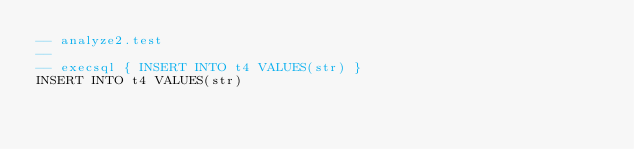Convert code to text. <code><loc_0><loc_0><loc_500><loc_500><_SQL_>-- analyze2.test
-- 
-- execsql { INSERT INTO t4 VALUES(str) }
INSERT INTO t4 VALUES(str)
</code> 